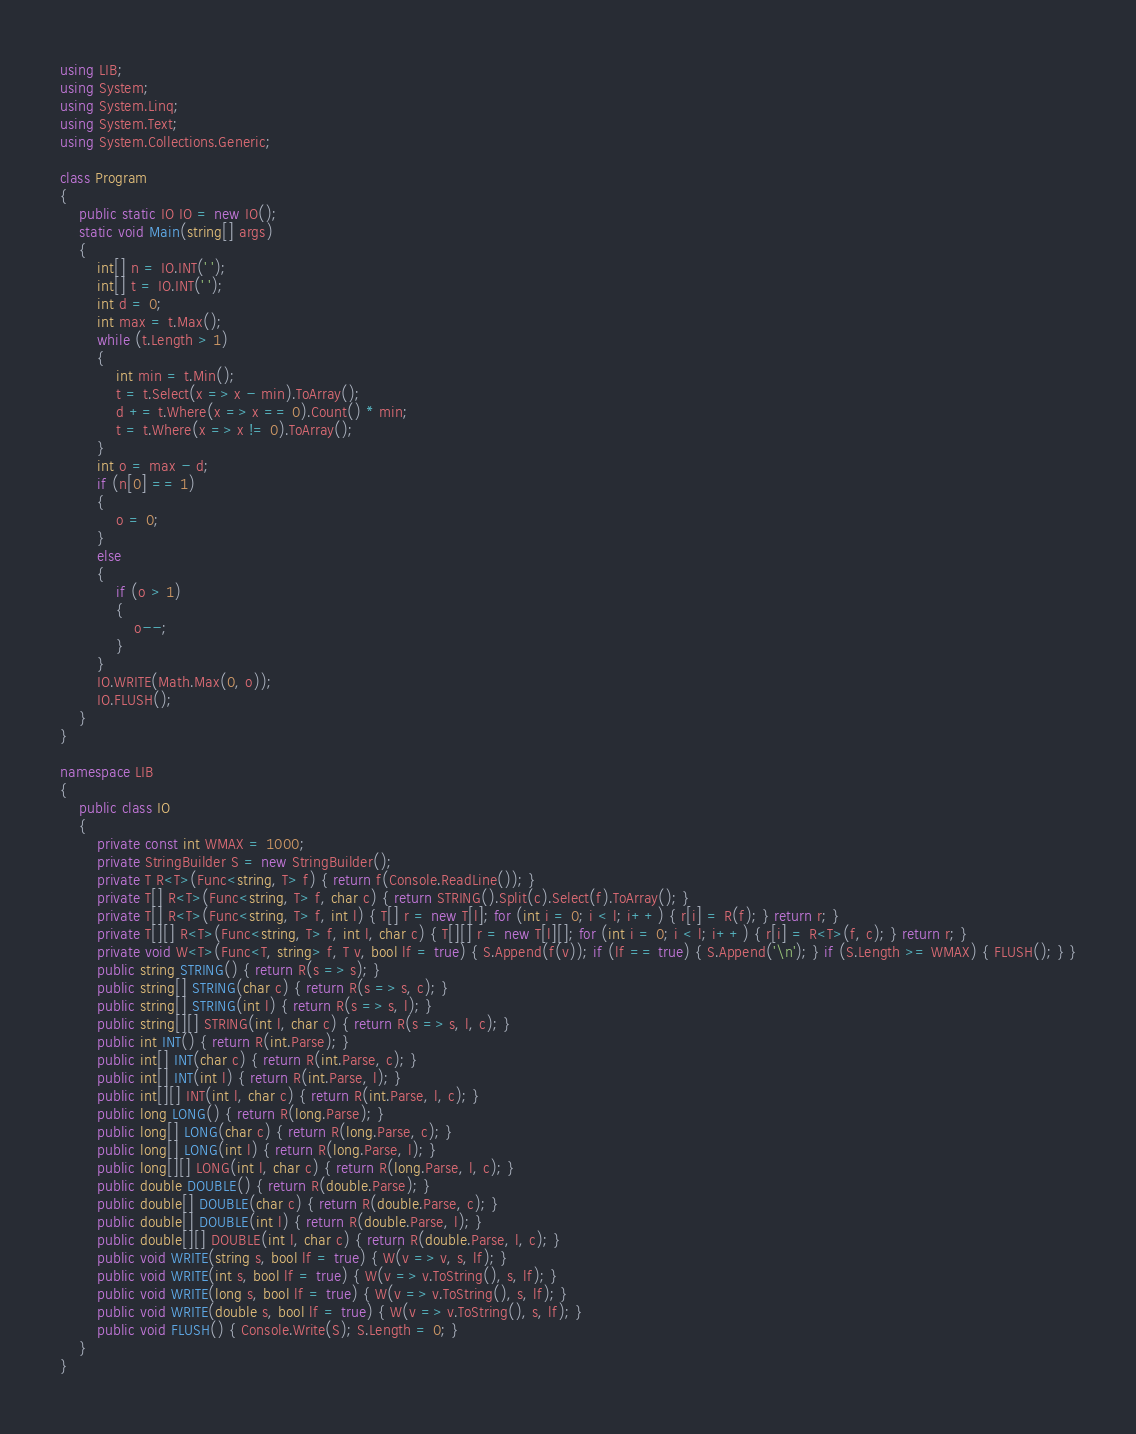<code> <loc_0><loc_0><loc_500><loc_500><_C#_>using LIB;
using System;
using System.Linq;
using System.Text;
using System.Collections.Generic;

class Program
{
    public static IO IO = new IO();
    static void Main(string[] args)
    {
        int[] n = IO.INT(' ');
        int[] t = IO.INT(' ');
        int d = 0;
        int max = t.Max();
        while (t.Length > 1)
        {
            int min = t.Min();
            t = t.Select(x => x - min).ToArray();
            d += t.Where(x => x == 0).Count() * min;
            t = t.Where(x => x != 0).ToArray();
        }
        int o = max - d;
        if (n[0] == 1)
        {
            o = 0;
        }
        else
        {
            if (o > 1)
            {
                o--;
            }
        }
        IO.WRITE(Math.Max(0, o));
        IO.FLUSH();
    }
}

namespace LIB
{
    public class IO
    {
        private const int WMAX = 1000;
        private StringBuilder S = new StringBuilder();
        private T R<T>(Func<string, T> f) { return f(Console.ReadLine()); }
        private T[] R<T>(Func<string, T> f, char c) { return STRING().Split(c).Select(f).ToArray(); }
        private T[] R<T>(Func<string, T> f, int l) { T[] r = new T[l]; for (int i = 0; i < l; i++) { r[i] = R(f); } return r; }
        private T[][] R<T>(Func<string, T> f, int l, char c) { T[][] r = new T[l][]; for (int i = 0; i < l; i++) { r[i] = R<T>(f, c); } return r; }
        private void W<T>(Func<T, string> f, T v, bool lf = true) { S.Append(f(v)); if (lf == true) { S.Append('\n'); } if (S.Length >= WMAX) { FLUSH(); } }
        public string STRING() { return R(s => s); }
        public string[] STRING(char c) { return R(s => s, c); }
        public string[] STRING(int l) { return R(s => s, l); }
        public string[][] STRING(int l, char c) { return R(s => s, l, c); }
        public int INT() { return R(int.Parse); }
        public int[] INT(char c) { return R(int.Parse, c); }
        public int[] INT(int l) { return R(int.Parse, l); }
        public int[][] INT(int l, char c) { return R(int.Parse, l, c); }
        public long LONG() { return R(long.Parse); }
        public long[] LONG(char c) { return R(long.Parse, c); }
        public long[] LONG(int l) { return R(long.Parse, l); }
        public long[][] LONG(int l, char c) { return R(long.Parse, l, c); }
        public double DOUBLE() { return R(double.Parse); }
        public double[] DOUBLE(char c) { return R(double.Parse, c); }
        public double[] DOUBLE(int l) { return R(double.Parse, l); }
        public double[][] DOUBLE(int l, char c) { return R(double.Parse, l, c); }
        public void WRITE(string s, bool lf = true) { W(v => v, s, lf); }
        public void WRITE(int s, bool lf = true) { W(v => v.ToString(), s, lf); }
        public void WRITE(long s, bool lf = true) { W(v => v.ToString(), s, lf); }
        public void WRITE(double s, bool lf = true) { W(v => v.ToString(), s, lf); }
        public void FLUSH() { Console.Write(S); S.Length = 0; }
    }
}</code> 